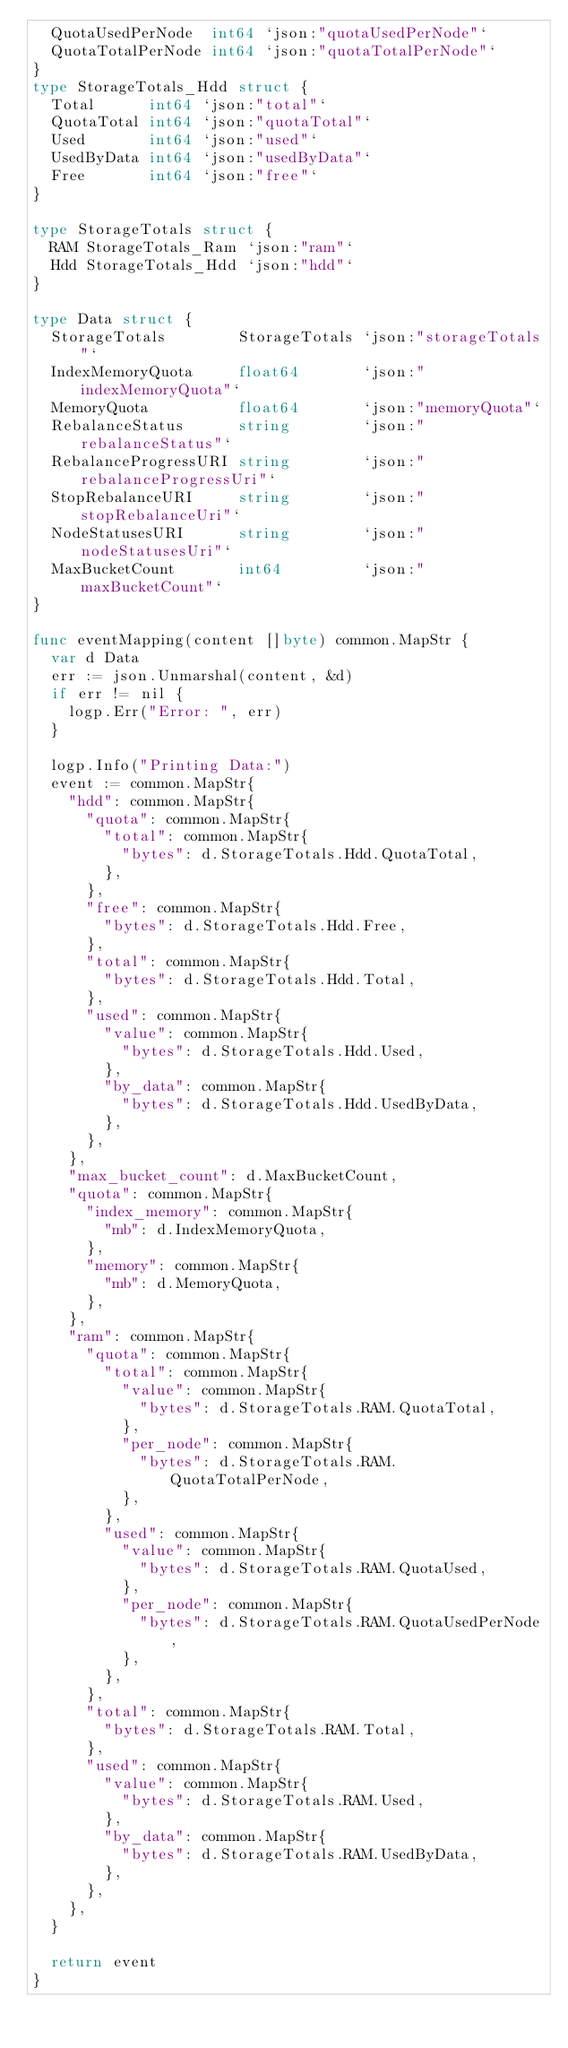Convert code to text. <code><loc_0><loc_0><loc_500><loc_500><_Go_>	QuotaUsedPerNode  int64 `json:"quotaUsedPerNode"`
	QuotaTotalPerNode int64 `json:"quotaTotalPerNode"`
}
type StorageTotals_Hdd struct {
	Total      int64 `json:"total"`
	QuotaTotal int64 `json:"quotaTotal"`
	Used       int64 `json:"used"`
	UsedByData int64 `json:"usedByData"`
	Free       int64 `json:"free"`
}

type StorageTotals struct {
	RAM StorageTotals_Ram `json:"ram"`
	Hdd StorageTotals_Hdd `json:"hdd"`
}

type Data struct {
	StorageTotals        StorageTotals `json:"storageTotals"`
	IndexMemoryQuota     float64       `json:"indexMemoryQuota"`
	MemoryQuota          float64       `json:"memoryQuota"`
	RebalanceStatus      string        `json:"rebalanceStatus"`
	RebalanceProgressURI string        `json:"rebalanceProgressUri"`
	StopRebalanceURI     string        `json:"stopRebalanceUri"`
	NodeStatusesURI      string        `json:"nodeStatusesUri"`
	MaxBucketCount       int64         `json:"maxBucketCount"`
}

func eventMapping(content []byte) common.MapStr {
	var d Data
	err := json.Unmarshal(content, &d)
	if err != nil {
		logp.Err("Error: ", err)
	}

	logp.Info("Printing Data:")
	event := common.MapStr{
		"hdd": common.MapStr{
			"quota": common.MapStr{
				"total": common.MapStr{
					"bytes": d.StorageTotals.Hdd.QuotaTotal,
				},
			},
			"free": common.MapStr{
				"bytes": d.StorageTotals.Hdd.Free,
			},
			"total": common.MapStr{
				"bytes": d.StorageTotals.Hdd.Total,
			},
			"used": common.MapStr{
				"value": common.MapStr{
					"bytes": d.StorageTotals.Hdd.Used,
				},
				"by_data": common.MapStr{
					"bytes": d.StorageTotals.Hdd.UsedByData,
				},
			},
		},
		"max_bucket_count": d.MaxBucketCount,
		"quota": common.MapStr{
			"index_memory": common.MapStr{
				"mb": d.IndexMemoryQuota,
			},
			"memory": common.MapStr{
				"mb": d.MemoryQuota,
			},
		},
		"ram": common.MapStr{
			"quota": common.MapStr{
				"total": common.MapStr{
					"value": common.MapStr{
						"bytes": d.StorageTotals.RAM.QuotaTotal,
					},
					"per_node": common.MapStr{
						"bytes": d.StorageTotals.RAM.QuotaTotalPerNode,
					},
				},
				"used": common.MapStr{
					"value": common.MapStr{
						"bytes": d.StorageTotals.RAM.QuotaUsed,
					},
					"per_node": common.MapStr{
						"bytes": d.StorageTotals.RAM.QuotaUsedPerNode,
					},
				},
			},
			"total": common.MapStr{
				"bytes": d.StorageTotals.RAM.Total,
			},
			"used": common.MapStr{
				"value": common.MapStr{
					"bytes": d.StorageTotals.RAM.Used,
				},
				"by_data": common.MapStr{
					"bytes": d.StorageTotals.RAM.UsedByData,
				},
			},
		},
	}

	return event
}
</code> 